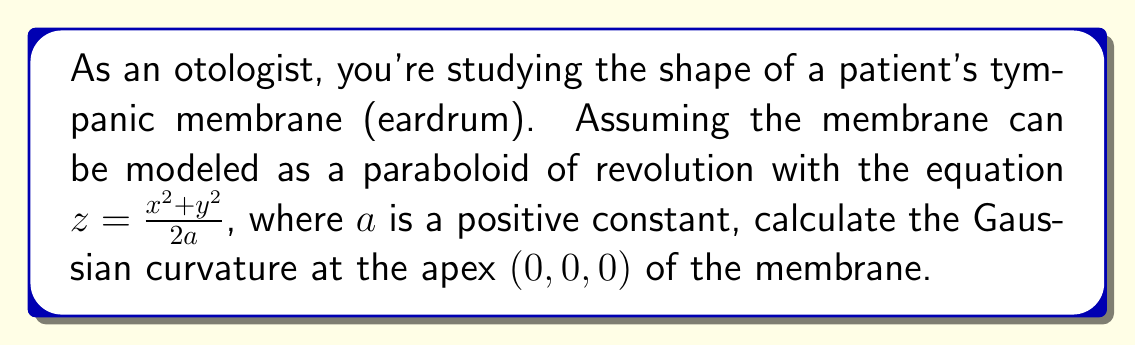What is the answer to this math problem? To find the Gaussian curvature of the tympanic membrane modeled as a paraboloid of revolution, we'll follow these steps:

1) The paraboloid is given by the equation $z = \frac{x^2 + y^2}{2a}$. We can parameterize this surface as:

   $r(x,y) = (x, y, \frac{x^2 + y^2}{2a})$

2) Calculate the partial derivatives:
   $r_x = (1, 0, \frac{x}{a})$
   $r_y = (0, 1, \frac{y}{a})$

3) Calculate the second partial derivatives:
   $r_{xx} = (0, 0, \frac{1}{a})$
   $r_{yy} = (0, 0, \frac{1}{a})$
   $r_{xy} = r_{yx} = (0, 0, 0)$

4) The first fundamental form coefficients are:
   $E = r_x \cdot r_x = 1 + \frac{x^2}{a^2}$
   $F = r_x \cdot r_y = \frac{xy}{a^2}$
   $G = r_y \cdot r_y = 1 + \frac{y^2}{a^2}$

5) The second fundamental form coefficients are:
   $L = \frac{r_{xx} \cdot (r_x \times r_y)}{|r_x \times r_y|} = \frac{1}{a\sqrt{1 + \frac{x^2 + y^2}{a^2}}}$
   $M = \frac{r_{xy} \cdot (r_x \times r_y)}{|r_x \times r_y|} = 0$
   $N = \frac{r_{yy} \cdot (r_x \times r_y)}{|r_x \times r_y|} = \frac{1}{a\sqrt{1 + \frac{x^2 + y^2}{a^2}}}$

6) The Gaussian curvature is given by:
   $K = \frac{LN - M^2}{EG - F^2}$

7) At the apex (0, 0, 0), we have:
   $E = G = 1$, $F = 0$
   $L = N = \frac{1}{a}$, $M = 0$

8) Substituting these values:
   $K = \frac{(\frac{1}{a})(\frac{1}{a}) - 0^2}{(1)(1) - 0^2} = \frac{1}{a^2}$

Therefore, the Gaussian curvature at the apex of the tympanic membrane is $\frac{1}{a^2}$.
Answer: $\frac{1}{a^2}$ 